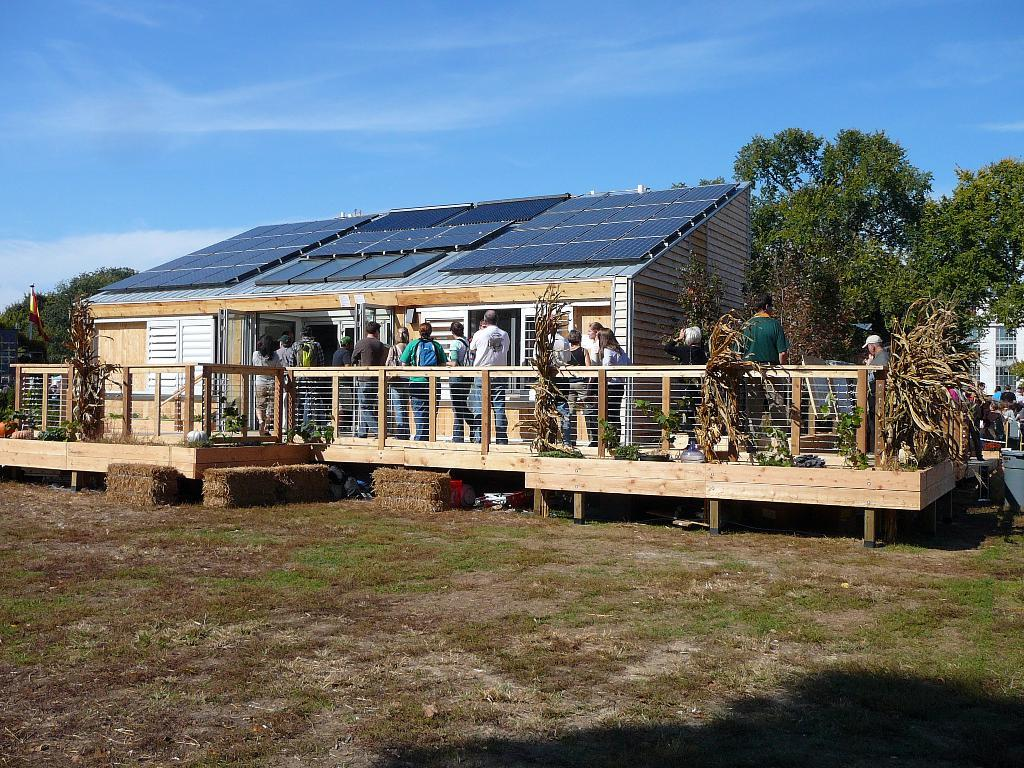What type of vegetation is at the bottom of the image? There is grass at the bottom of the image. What can be seen in the middle of the image? There are trees, people, dry grass, a railing, solar panels, buildings, and other objects present in the middle of the image. What is the condition of the grass in the middle of the image? The grass in the middle of the image is dry. What is visible at the top of the image? The sky is visible at the top of the image. What type of silk is being spun by the people in the image? There is no silk or spinning activity present in the image. What is the chance of sleet falling in the image? The image does not provide any information about the weather, so it is impossible to determine the chance of sleet falling. 